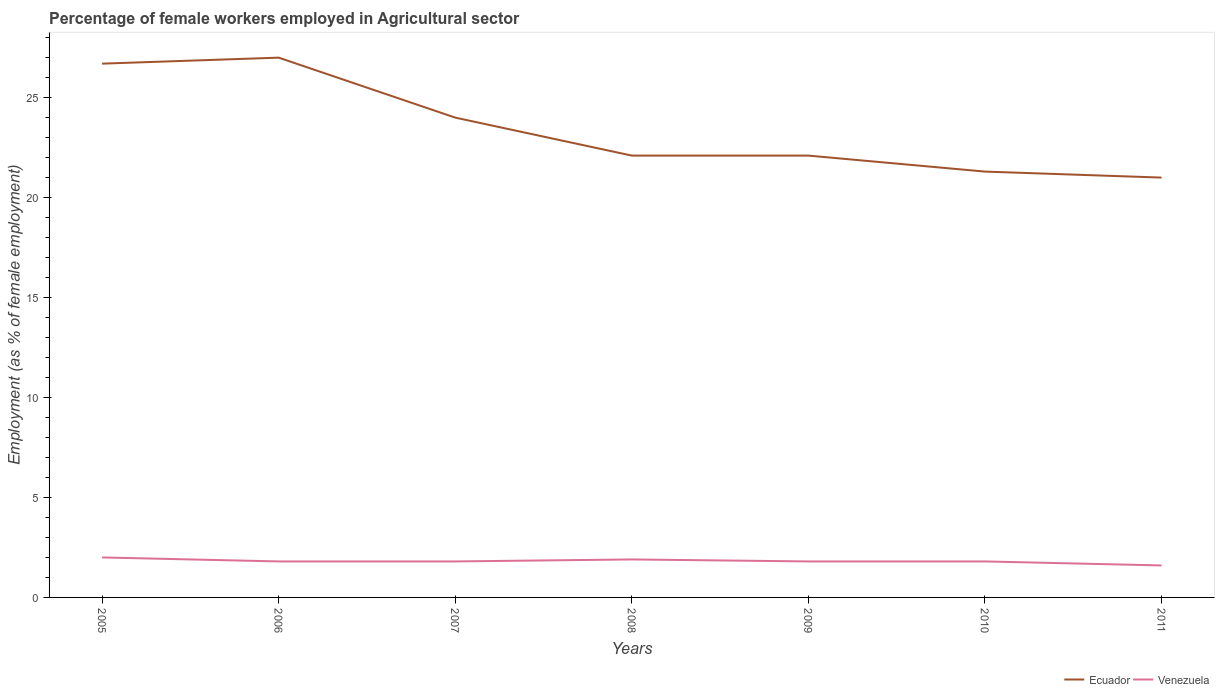In which year was the percentage of females employed in Agricultural sector in Venezuela maximum?
Give a very brief answer. 2011. What is the total percentage of females employed in Agricultural sector in Ecuador in the graph?
Give a very brief answer. 2.7. What is the difference between the highest and the second highest percentage of females employed in Agricultural sector in Venezuela?
Keep it short and to the point. 0.4. What is the difference between the highest and the lowest percentage of females employed in Agricultural sector in Venezuela?
Give a very brief answer. 2. What is the difference between two consecutive major ticks on the Y-axis?
Provide a succinct answer. 5. Does the graph contain grids?
Provide a succinct answer. No. Where does the legend appear in the graph?
Provide a short and direct response. Bottom right. How many legend labels are there?
Your answer should be very brief. 2. What is the title of the graph?
Give a very brief answer. Percentage of female workers employed in Agricultural sector. What is the label or title of the Y-axis?
Offer a very short reply. Employment (as % of female employment). What is the Employment (as % of female employment) in Ecuador in 2005?
Give a very brief answer. 26.7. What is the Employment (as % of female employment) of Venezuela in 2006?
Your answer should be compact. 1.8. What is the Employment (as % of female employment) in Ecuador in 2007?
Your answer should be compact. 24. What is the Employment (as % of female employment) of Venezuela in 2007?
Ensure brevity in your answer.  1.8. What is the Employment (as % of female employment) of Ecuador in 2008?
Offer a terse response. 22.1. What is the Employment (as % of female employment) of Venezuela in 2008?
Offer a very short reply. 1.9. What is the Employment (as % of female employment) of Ecuador in 2009?
Provide a short and direct response. 22.1. What is the Employment (as % of female employment) of Venezuela in 2009?
Your answer should be very brief. 1.8. What is the Employment (as % of female employment) in Ecuador in 2010?
Make the answer very short. 21.3. What is the Employment (as % of female employment) of Venezuela in 2010?
Your answer should be very brief. 1.8. What is the Employment (as % of female employment) of Ecuador in 2011?
Keep it short and to the point. 21. What is the Employment (as % of female employment) of Venezuela in 2011?
Provide a succinct answer. 1.6. Across all years, what is the minimum Employment (as % of female employment) of Ecuador?
Offer a terse response. 21. Across all years, what is the minimum Employment (as % of female employment) in Venezuela?
Ensure brevity in your answer.  1.6. What is the total Employment (as % of female employment) in Ecuador in the graph?
Make the answer very short. 164.2. What is the total Employment (as % of female employment) in Venezuela in the graph?
Give a very brief answer. 12.7. What is the difference between the Employment (as % of female employment) of Venezuela in 2005 and that in 2006?
Your answer should be compact. 0.2. What is the difference between the Employment (as % of female employment) of Ecuador in 2005 and that in 2007?
Make the answer very short. 2.7. What is the difference between the Employment (as % of female employment) of Venezuela in 2005 and that in 2008?
Give a very brief answer. 0.1. What is the difference between the Employment (as % of female employment) of Ecuador in 2005 and that in 2010?
Offer a very short reply. 5.4. What is the difference between the Employment (as % of female employment) in Venezuela in 2005 and that in 2010?
Make the answer very short. 0.2. What is the difference between the Employment (as % of female employment) in Ecuador in 2006 and that in 2007?
Give a very brief answer. 3. What is the difference between the Employment (as % of female employment) of Venezuela in 2006 and that in 2007?
Your answer should be compact. 0. What is the difference between the Employment (as % of female employment) in Venezuela in 2006 and that in 2008?
Keep it short and to the point. -0.1. What is the difference between the Employment (as % of female employment) in Venezuela in 2006 and that in 2009?
Provide a succinct answer. 0. What is the difference between the Employment (as % of female employment) of Ecuador in 2006 and that in 2010?
Your answer should be very brief. 5.7. What is the difference between the Employment (as % of female employment) in Venezuela in 2006 and that in 2011?
Ensure brevity in your answer.  0.2. What is the difference between the Employment (as % of female employment) in Ecuador in 2007 and that in 2008?
Offer a very short reply. 1.9. What is the difference between the Employment (as % of female employment) in Ecuador in 2007 and that in 2010?
Keep it short and to the point. 2.7. What is the difference between the Employment (as % of female employment) in Venezuela in 2007 and that in 2010?
Keep it short and to the point. 0. What is the difference between the Employment (as % of female employment) of Venezuela in 2007 and that in 2011?
Keep it short and to the point. 0.2. What is the difference between the Employment (as % of female employment) of Ecuador in 2008 and that in 2009?
Make the answer very short. 0. What is the difference between the Employment (as % of female employment) in Ecuador in 2008 and that in 2011?
Offer a very short reply. 1.1. What is the difference between the Employment (as % of female employment) of Ecuador in 2009 and that in 2010?
Your response must be concise. 0.8. What is the difference between the Employment (as % of female employment) in Venezuela in 2009 and that in 2010?
Ensure brevity in your answer.  0. What is the difference between the Employment (as % of female employment) in Ecuador in 2009 and that in 2011?
Offer a terse response. 1.1. What is the difference between the Employment (as % of female employment) in Ecuador in 2010 and that in 2011?
Offer a terse response. 0.3. What is the difference between the Employment (as % of female employment) of Ecuador in 2005 and the Employment (as % of female employment) of Venezuela in 2006?
Ensure brevity in your answer.  24.9. What is the difference between the Employment (as % of female employment) in Ecuador in 2005 and the Employment (as % of female employment) in Venezuela in 2007?
Offer a very short reply. 24.9. What is the difference between the Employment (as % of female employment) in Ecuador in 2005 and the Employment (as % of female employment) in Venezuela in 2008?
Give a very brief answer. 24.8. What is the difference between the Employment (as % of female employment) in Ecuador in 2005 and the Employment (as % of female employment) in Venezuela in 2009?
Provide a succinct answer. 24.9. What is the difference between the Employment (as % of female employment) of Ecuador in 2005 and the Employment (as % of female employment) of Venezuela in 2010?
Your answer should be compact. 24.9. What is the difference between the Employment (as % of female employment) in Ecuador in 2005 and the Employment (as % of female employment) in Venezuela in 2011?
Your answer should be very brief. 25.1. What is the difference between the Employment (as % of female employment) of Ecuador in 2006 and the Employment (as % of female employment) of Venezuela in 2007?
Provide a succinct answer. 25.2. What is the difference between the Employment (as % of female employment) in Ecuador in 2006 and the Employment (as % of female employment) in Venezuela in 2008?
Provide a succinct answer. 25.1. What is the difference between the Employment (as % of female employment) in Ecuador in 2006 and the Employment (as % of female employment) in Venezuela in 2009?
Your answer should be compact. 25.2. What is the difference between the Employment (as % of female employment) of Ecuador in 2006 and the Employment (as % of female employment) of Venezuela in 2010?
Your response must be concise. 25.2. What is the difference between the Employment (as % of female employment) in Ecuador in 2006 and the Employment (as % of female employment) in Venezuela in 2011?
Your answer should be compact. 25.4. What is the difference between the Employment (as % of female employment) of Ecuador in 2007 and the Employment (as % of female employment) of Venezuela in 2008?
Your response must be concise. 22.1. What is the difference between the Employment (as % of female employment) of Ecuador in 2007 and the Employment (as % of female employment) of Venezuela in 2009?
Offer a terse response. 22.2. What is the difference between the Employment (as % of female employment) of Ecuador in 2007 and the Employment (as % of female employment) of Venezuela in 2010?
Provide a succinct answer. 22.2. What is the difference between the Employment (as % of female employment) of Ecuador in 2007 and the Employment (as % of female employment) of Venezuela in 2011?
Give a very brief answer. 22.4. What is the difference between the Employment (as % of female employment) in Ecuador in 2008 and the Employment (as % of female employment) in Venezuela in 2009?
Offer a very short reply. 20.3. What is the difference between the Employment (as % of female employment) of Ecuador in 2008 and the Employment (as % of female employment) of Venezuela in 2010?
Make the answer very short. 20.3. What is the difference between the Employment (as % of female employment) of Ecuador in 2009 and the Employment (as % of female employment) of Venezuela in 2010?
Your answer should be very brief. 20.3. What is the average Employment (as % of female employment) of Ecuador per year?
Make the answer very short. 23.46. What is the average Employment (as % of female employment) in Venezuela per year?
Your answer should be very brief. 1.81. In the year 2005, what is the difference between the Employment (as % of female employment) of Ecuador and Employment (as % of female employment) of Venezuela?
Offer a very short reply. 24.7. In the year 2006, what is the difference between the Employment (as % of female employment) in Ecuador and Employment (as % of female employment) in Venezuela?
Provide a succinct answer. 25.2. In the year 2008, what is the difference between the Employment (as % of female employment) in Ecuador and Employment (as % of female employment) in Venezuela?
Provide a short and direct response. 20.2. In the year 2009, what is the difference between the Employment (as % of female employment) of Ecuador and Employment (as % of female employment) of Venezuela?
Offer a terse response. 20.3. What is the ratio of the Employment (as % of female employment) of Ecuador in 2005 to that in 2006?
Your response must be concise. 0.99. What is the ratio of the Employment (as % of female employment) in Venezuela in 2005 to that in 2006?
Offer a very short reply. 1.11. What is the ratio of the Employment (as % of female employment) of Ecuador in 2005 to that in 2007?
Your answer should be compact. 1.11. What is the ratio of the Employment (as % of female employment) in Ecuador in 2005 to that in 2008?
Offer a terse response. 1.21. What is the ratio of the Employment (as % of female employment) of Venezuela in 2005 to that in 2008?
Provide a short and direct response. 1.05. What is the ratio of the Employment (as % of female employment) in Ecuador in 2005 to that in 2009?
Provide a succinct answer. 1.21. What is the ratio of the Employment (as % of female employment) of Ecuador in 2005 to that in 2010?
Your answer should be compact. 1.25. What is the ratio of the Employment (as % of female employment) in Venezuela in 2005 to that in 2010?
Ensure brevity in your answer.  1.11. What is the ratio of the Employment (as % of female employment) in Ecuador in 2005 to that in 2011?
Your response must be concise. 1.27. What is the ratio of the Employment (as % of female employment) of Venezuela in 2005 to that in 2011?
Your answer should be compact. 1.25. What is the ratio of the Employment (as % of female employment) in Ecuador in 2006 to that in 2007?
Your response must be concise. 1.12. What is the ratio of the Employment (as % of female employment) in Venezuela in 2006 to that in 2007?
Keep it short and to the point. 1. What is the ratio of the Employment (as % of female employment) of Ecuador in 2006 to that in 2008?
Your answer should be very brief. 1.22. What is the ratio of the Employment (as % of female employment) of Venezuela in 2006 to that in 2008?
Your answer should be compact. 0.95. What is the ratio of the Employment (as % of female employment) in Ecuador in 2006 to that in 2009?
Provide a short and direct response. 1.22. What is the ratio of the Employment (as % of female employment) in Venezuela in 2006 to that in 2009?
Your response must be concise. 1. What is the ratio of the Employment (as % of female employment) of Ecuador in 2006 to that in 2010?
Ensure brevity in your answer.  1.27. What is the ratio of the Employment (as % of female employment) in Ecuador in 2006 to that in 2011?
Give a very brief answer. 1.29. What is the ratio of the Employment (as % of female employment) in Ecuador in 2007 to that in 2008?
Ensure brevity in your answer.  1.09. What is the ratio of the Employment (as % of female employment) of Venezuela in 2007 to that in 2008?
Your response must be concise. 0.95. What is the ratio of the Employment (as % of female employment) of Ecuador in 2007 to that in 2009?
Your answer should be very brief. 1.09. What is the ratio of the Employment (as % of female employment) in Ecuador in 2007 to that in 2010?
Your response must be concise. 1.13. What is the ratio of the Employment (as % of female employment) in Ecuador in 2007 to that in 2011?
Offer a terse response. 1.14. What is the ratio of the Employment (as % of female employment) of Venezuela in 2008 to that in 2009?
Ensure brevity in your answer.  1.06. What is the ratio of the Employment (as % of female employment) of Ecuador in 2008 to that in 2010?
Your response must be concise. 1.04. What is the ratio of the Employment (as % of female employment) in Venezuela in 2008 to that in 2010?
Give a very brief answer. 1.06. What is the ratio of the Employment (as % of female employment) in Ecuador in 2008 to that in 2011?
Give a very brief answer. 1.05. What is the ratio of the Employment (as % of female employment) in Venezuela in 2008 to that in 2011?
Provide a short and direct response. 1.19. What is the ratio of the Employment (as % of female employment) of Ecuador in 2009 to that in 2010?
Make the answer very short. 1.04. What is the ratio of the Employment (as % of female employment) in Venezuela in 2009 to that in 2010?
Your answer should be compact. 1. What is the ratio of the Employment (as % of female employment) of Ecuador in 2009 to that in 2011?
Your answer should be compact. 1.05. What is the ratio of the Employment (as % of female employment) of Venezuela in 2009 to that in 2011?
Offer a very short reply. 1.12. What is the ratio of the Employment (as % of female employment) of Ecuador in 2010 to that in 2011?
Offer a very short reply. 1.01. What is the difference between the highest and the second highest Employment (as % of female employment) in Venezuela?
Make the answer very short. 0.1. What is the difference between the highest and the lowest Employment (as % of female employment) of Ecuador?
Your answer should be compact. 6. 